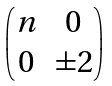<formula> <loc_0><loc_0><loc_500><loc_500>\begin{pmatrix} n & 0 \\ 0 & \pm 2 \\ \end{pmatrix}</formula> 